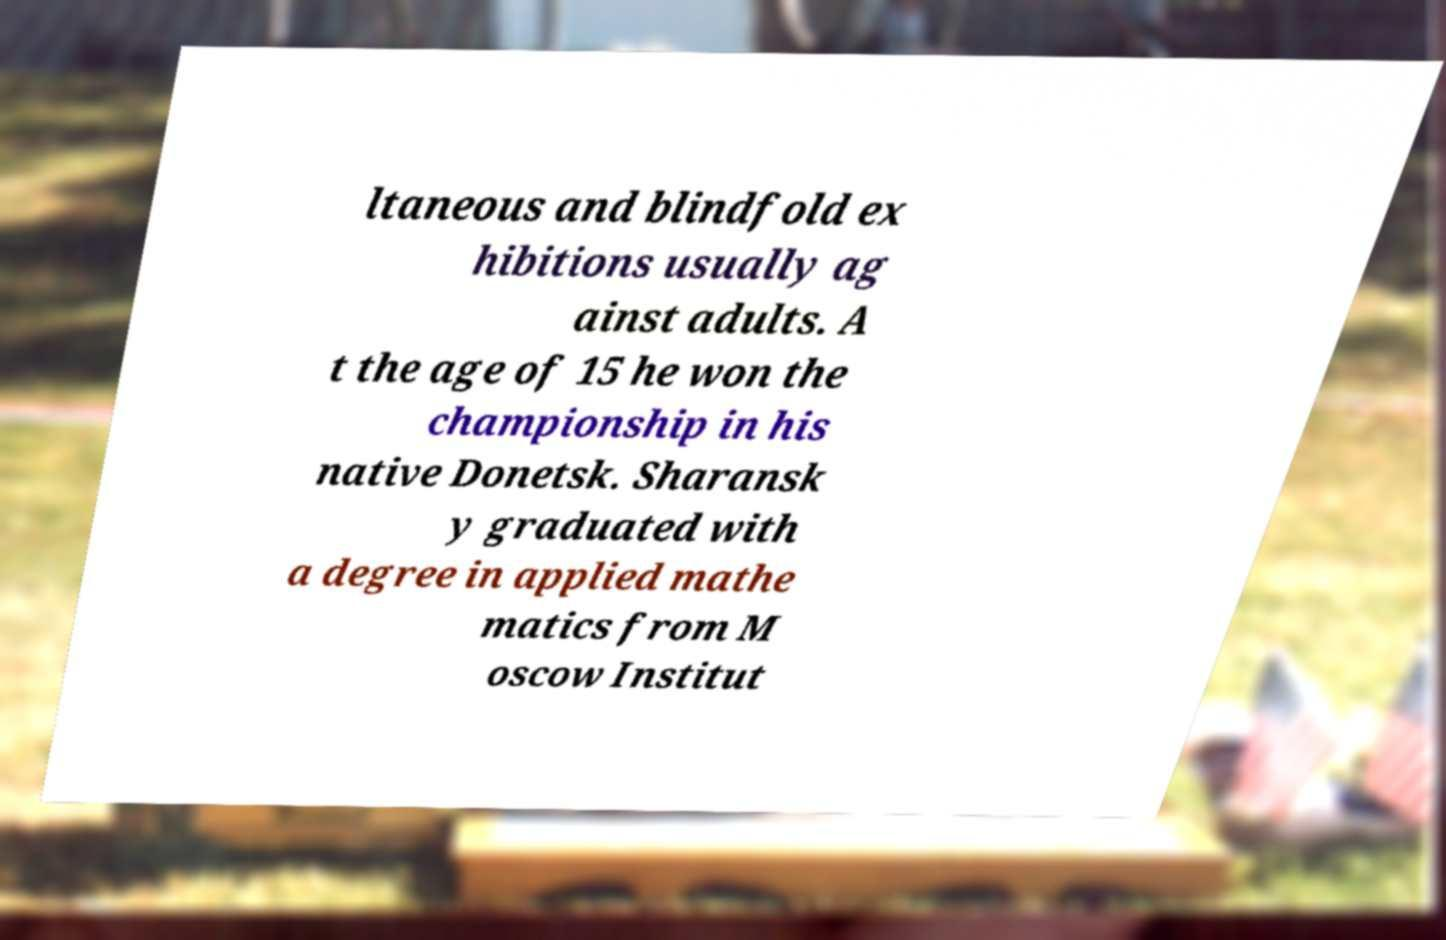Can you read and provide the text displayed in the image?This photo seems to have some interesting text. Can you extract and type it out for me? ltaneous and blindfold ex hibitions usually ag ainst adults. A t the age of 15 he won the championship in his native Donetsk. Sharansk y graduated with a degree in applied mathe matics from M oscow Institut 